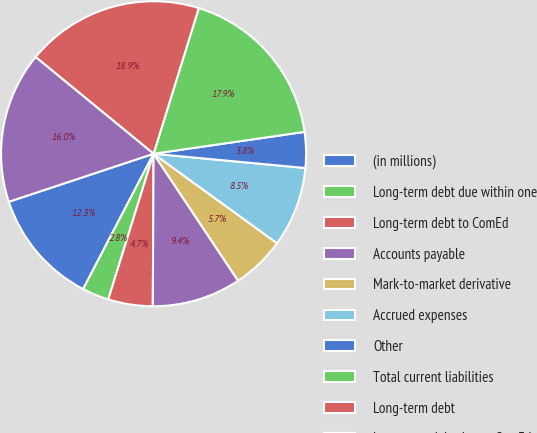Convert chart to OTSL. <chart><loc_0><loc_0><loc_500><loc_500><pie_chart><fcel>(in millions)<fcel>Long-term debt due within one<fcel>Long-term debt to ComEd<fcel>Accounts payable<fcel>Mark-to-market derivative<fcel>Accrued expenses<fcel>Other<fcel>Total current liabilities<fcel>Long-term debt<fcel>Long-term debt due to ComEd<nl><fcel>12.26%<fcel>2.84%<fcel>4.72%<fcel>9.43%<fcel>5.67%<fcel>8.49%<fcel>3.78%<fcel>17.92%<fcel>18.86%<fcel>16.03%<nl></chart> 